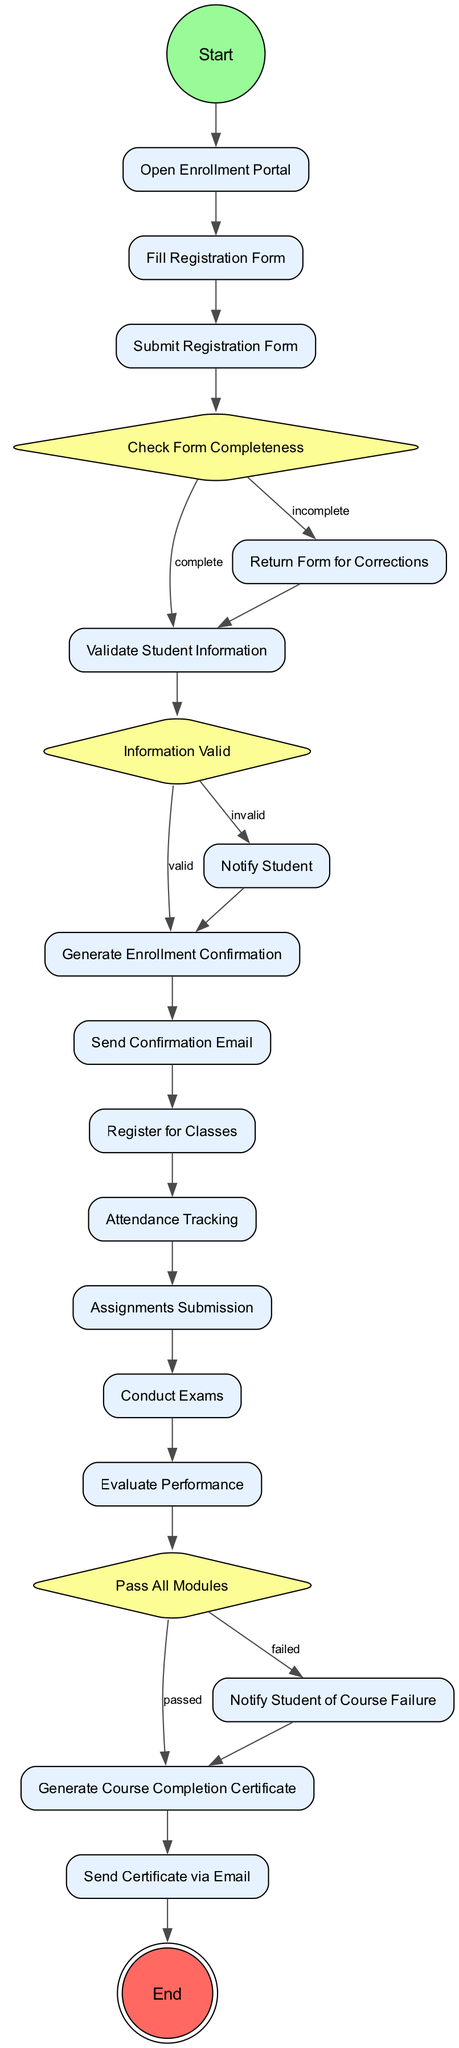What is the starting activity of the enrollment process? According to the diagram, the starting activity is labeled as "Start". This is shown as the first node in the sequence of activities.
Answer: Start How many actions are there in the enrollment process? The diagram consists of 12 actions listed among the activities, counting from "Open Enrollment Portal" to "Send Certificate via Email", which are all actions.
Answer: 12 What activity comes after "Fill Registration Form"? The diagram indicates that the next activity following "Fill Registration Form" is "Submit Registration Form". This is indicated by a direct edge connecting the two nodes.
Answer: Submit Registration Form What happens if the form is incomplete? If the form's completeness check indicates it is incomplete, the next step is "Return Form for Corrections", as denoted in the decision flow of the diagram.
Answer: Return Form for Corrections What is the final activity in the diagram? The last activity shown in the diagram is "End". This is represented as the final node where the process concludes.
Answer: End If a student's information is invalid, which action is taken? In the case of invalid information, the flow leads to "Notify Student", which is clearly outlined as the resultant action stemming from the corresponding decision node.
Answer: Notify Student What decision follows the completion of performance evaluation? After "Evaluate Performance", the next decision is whether the student has "Passed All Modules". This decision determines the subsequent action based on the evaluation result.
Answer: Pass All Modules What action occurs after generating the enrollment confirmation? Once "Generate Enrollment Confirmation" is completed, the next action is "Send Confirmation Email". This follows the logical progression of the enrollment activities.
Answer: Send Confirmation Email What is the purpose of the "Attendance Tracking" activity? "Attendance Tracking" is an action undertaken to monitor students’ presence and participation throughout the course duration. It serves as a crucial part of the educational process.
Answer: Monitor attendance 